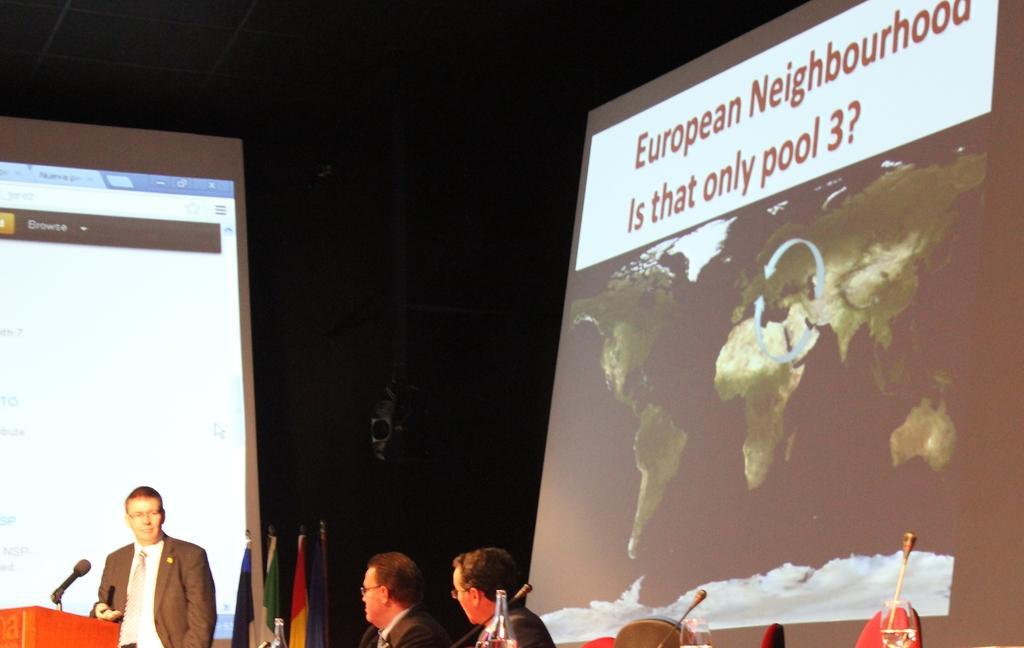Describe this image in one or two sentences. In the picture we can see two men wearing suit sitting on chairs behind table on which there are some microphones and in the background there is a person wearing suit, standing behind wooden podium on which there is microphone and there are some flags, we can see projector screen and on right side of the picture there is another projector screen. 